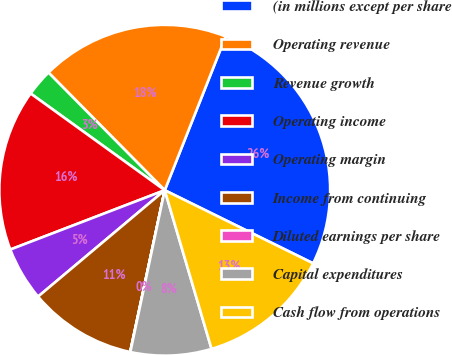Convert chart. <chart><loc_0><loc_0><loc_500><loc_500><pie_chart><fcel>(in millions except per share<fcel>Operating revenue<fcel>Revenue growth<fcel>Operating income<fcel>Operating margin<fcel>Income from continuing<fcel>Diluted earnings per share<fcel>Capital expenditures<fcel>Cash flow from operations<nl><fcel>26.28%<fcel>18.41%<fcel>2.65%<fcel>15.78%<fcel>5.28%<fcel>10.53%<fcel>0.02%<fcel>7.9%<fcel>13.15%<nl></chart> 